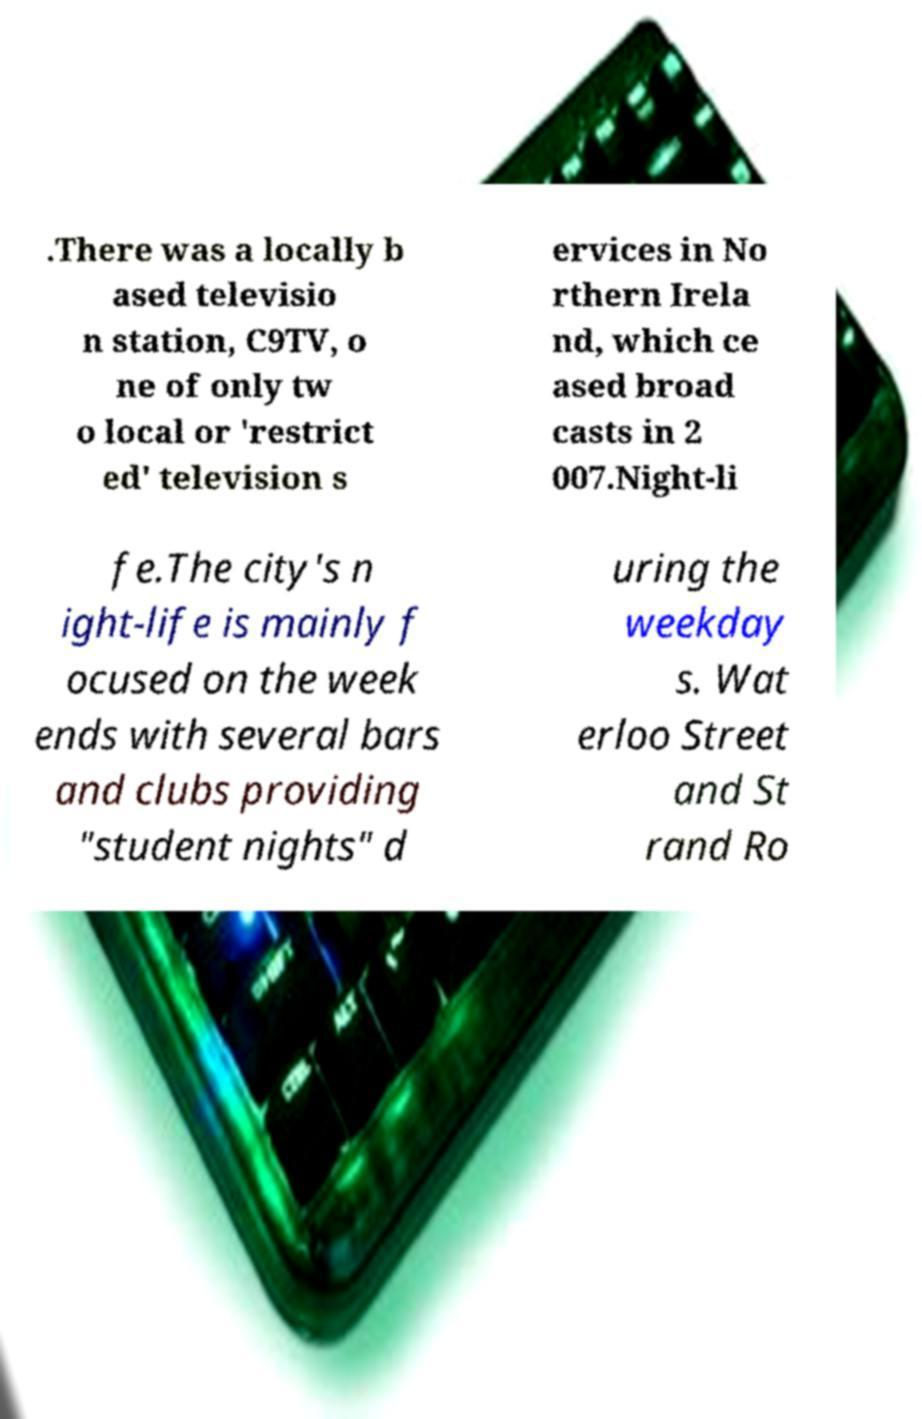Please read and relay the text visible in this image. What does it say? .There was a locally b ased televisio n station, C9TV, o ne of only tw o local or 'restrict ed' television s ervices in No rthern Irela nd, which ce ased broad casts in 2 007.Night-li fe.The city's n ight-life is mainly f ocused on the week ends with several bars and clubs providing "student nights" d uring the weekday s. Wat erloo Street and St rand Ro 